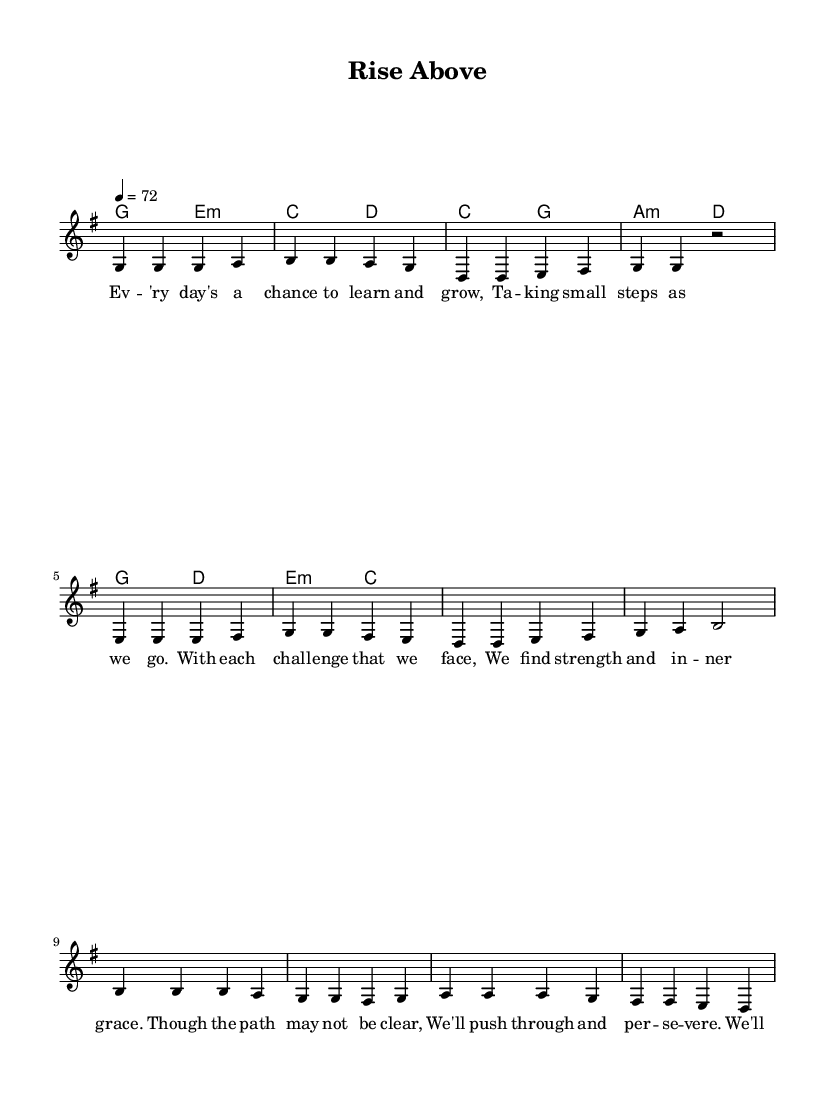What is the key signature of this music? The key signature is G major, which has one sharp (F#). This is identifiable by looking at the beginning of the music staff where the sharps are listed.
Answer: G major What is the time signature of this music? The time signature is 4/4, which means there are four beats in each measure and a quarter note receives one beat. This can be determined by looking at the time signature indicator at the beginning of the score.
Answer: 4/4 What is the tempo marking for this piece? The tempo marking is 72, indicating that the quarter note should be played at a rate of 72 beats per minute. The tempo is provided near the start of the score, specifically right after the time signature.
Answer: 72 What is the first note of the melody in the verse? The first note of the melody in the verse is G, as it is the starting note in the sequence given and marked in the staff.
Answer: G How many measures are in the chorus? The chorus consists of four measures, which can be counted by examining the measure lines and the number of complete groups of notes that fit within them.
Answer: 4 What type of chords are used in the pre-chorus? The chords used in the pre-chorus are C major and A minor, as indicated by the chord symbols written above the melody line. These can be verified by identifying the harmony section's chord progression.
Answer: C major and A minor What is the theme of the lyrics in this song? The theme of the lyrics is overcoming challenges, as they discuss personal growth and rising above difficulties. This is conveyed through the content of the lyrics provided under the melody.
Answer: Overcoming challenges 